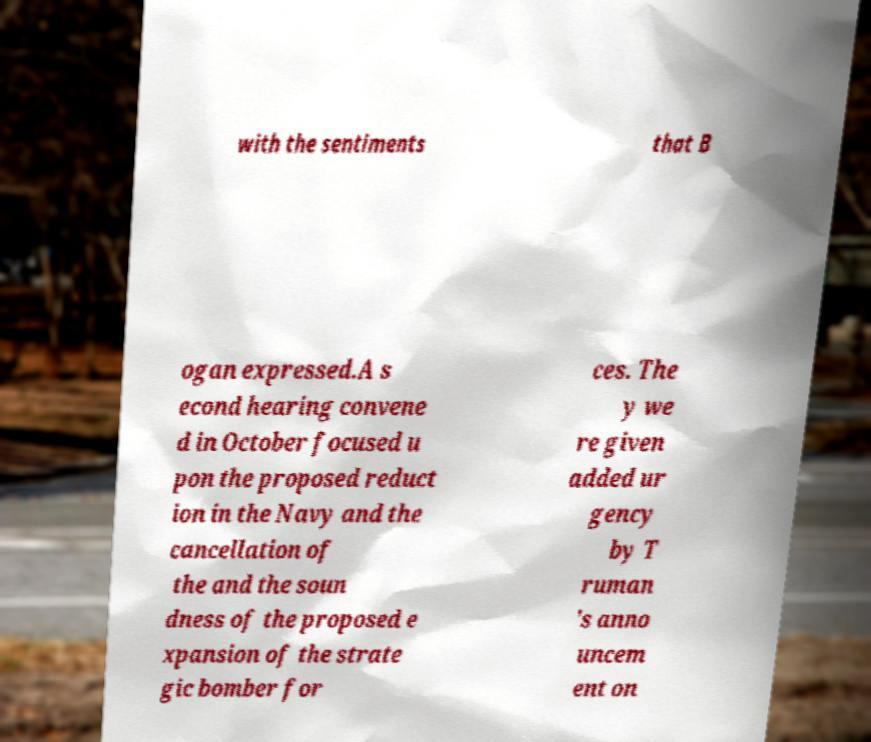I need the written content from this picture converted into text. Can you do that? with the sentiments that B ogan expressed.A s econd hearing convene d in October focused u pon the proposed reduct ion in the Navy and the cancellation of the and the soun dness of the proposed e xpansion of the strate gic bomber for ces. The y we re given added ur gency by T ruman 's anno uncem ent on 